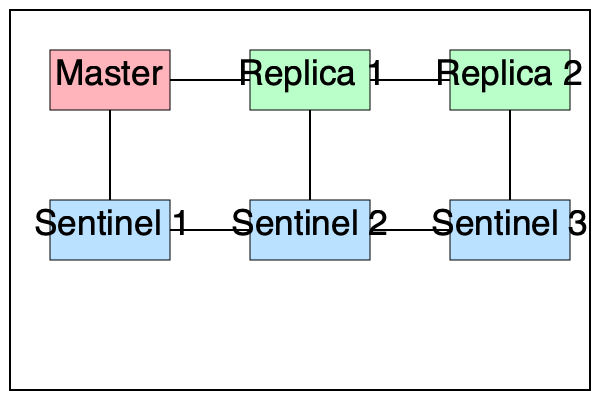In the Redis replication architecture shown above, what is the minimum number of Sentinel nodes that must agree to initiate a failover if the quorum is set to 2 and the majority is required for leader election? To understand the failover process in Redis Sentinel, let's break it down step-by-step:

1. Quorum: The quorum (set to 2 in this case) is the minimum number of Sentinel nodes that must agree that the master is down before initiating a failover process.

2. Leader Election: After reaching quorum, Sentinels must elect a leader to coordinate the failover. This election requires a majority of the Sentinel nodes to agree.

3. Total Sentinel Nodes: In the diagram, we can see 3 Sentinel nodes.

4. Majority Calculation: The majority is calculated as $\left\lfloor\frac{N}{2}\right\rfloor + 1$, where $N$ is the total number of Sentinel nodes. In this case:
   $$\left\lfloor\frac{3}{2}\right\rfloor + 1 = 1 + 1 = 2$$

5. Minimum Agreement: To satisfy both the quorum and the majority requirements:
   - At least 2 Sentinels must agree that the master is down (quorum).
   - At least 2 Sentinels must participate in leader election (majority).

Therefore, the minimum number of Sentinel nodes that must agree to initiate a failover is 2, which satisfies both the quorum and the majority requirements for leader election.
Answer: 2 Sentinel nodes 